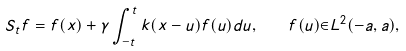Convert formula to latex. <formula><loc_0><loc_0><loc_500><loc_500>S _ { t } f = f ( x ) + \gamma \int _ { - t } ^ { t } k ( x - u ) f ( u ) d u , \quad f ( u ) { \in } L ^ { 2 } ( - a , a ) ,</formula> 